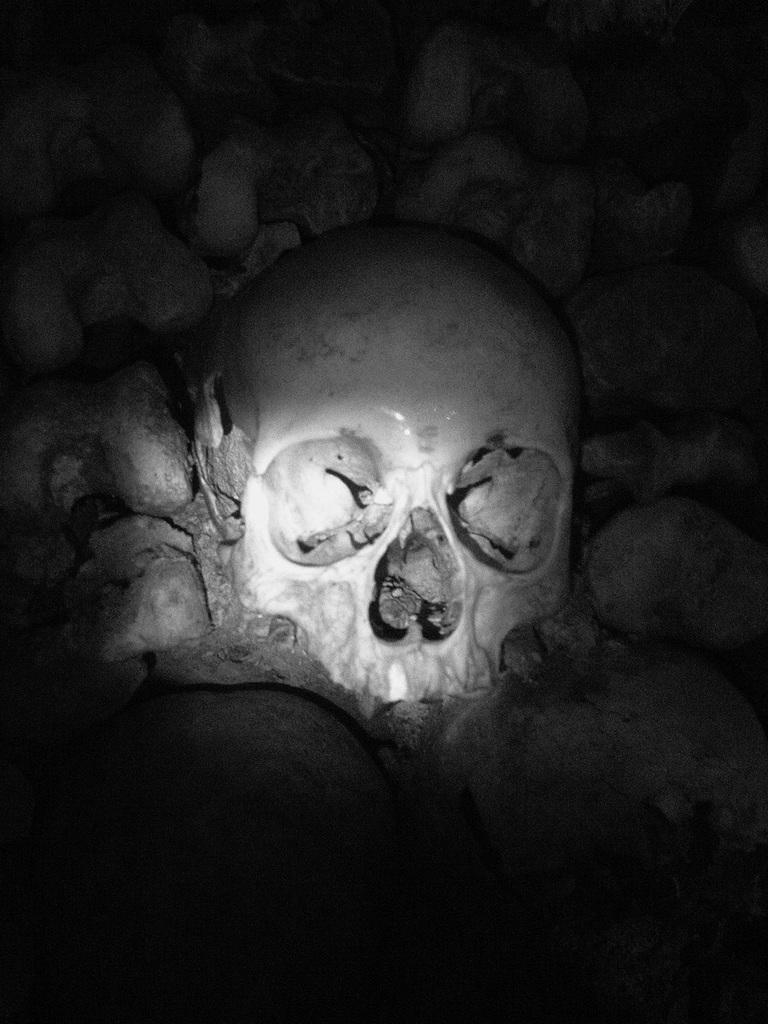What is the color scheme of the image? The image is black and white. What is the main subject of the image? There is a skull in the image. What else can be seen around the skull in the image? There are stones around the skull in the image. What is the governor doing in the image? There is no governor present in the image; it features a skull and stones. How does the skull move around in the image? The skull does not move around in the image; it is stationary. 